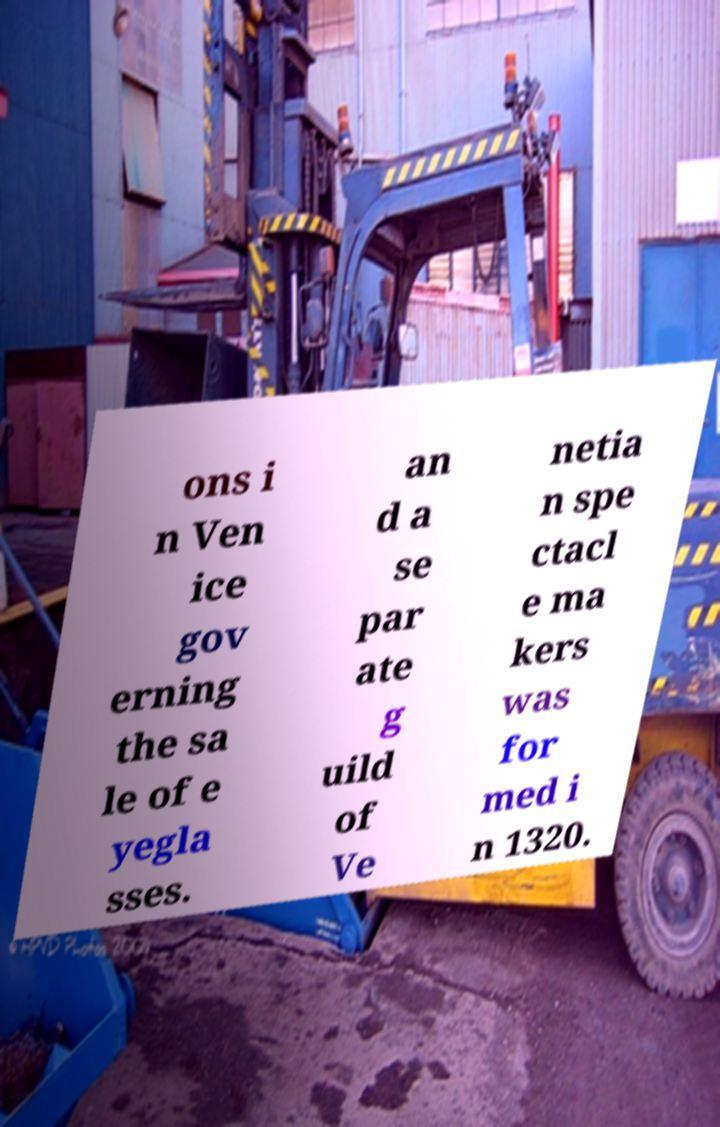Please identify and transcribe the text found in this image. ons i n Ven ice gov erning the sa le of e yegla sses. an d a se par ate g uild of Ve netia n spe ctacl e ma kers was for med i n 1320. 